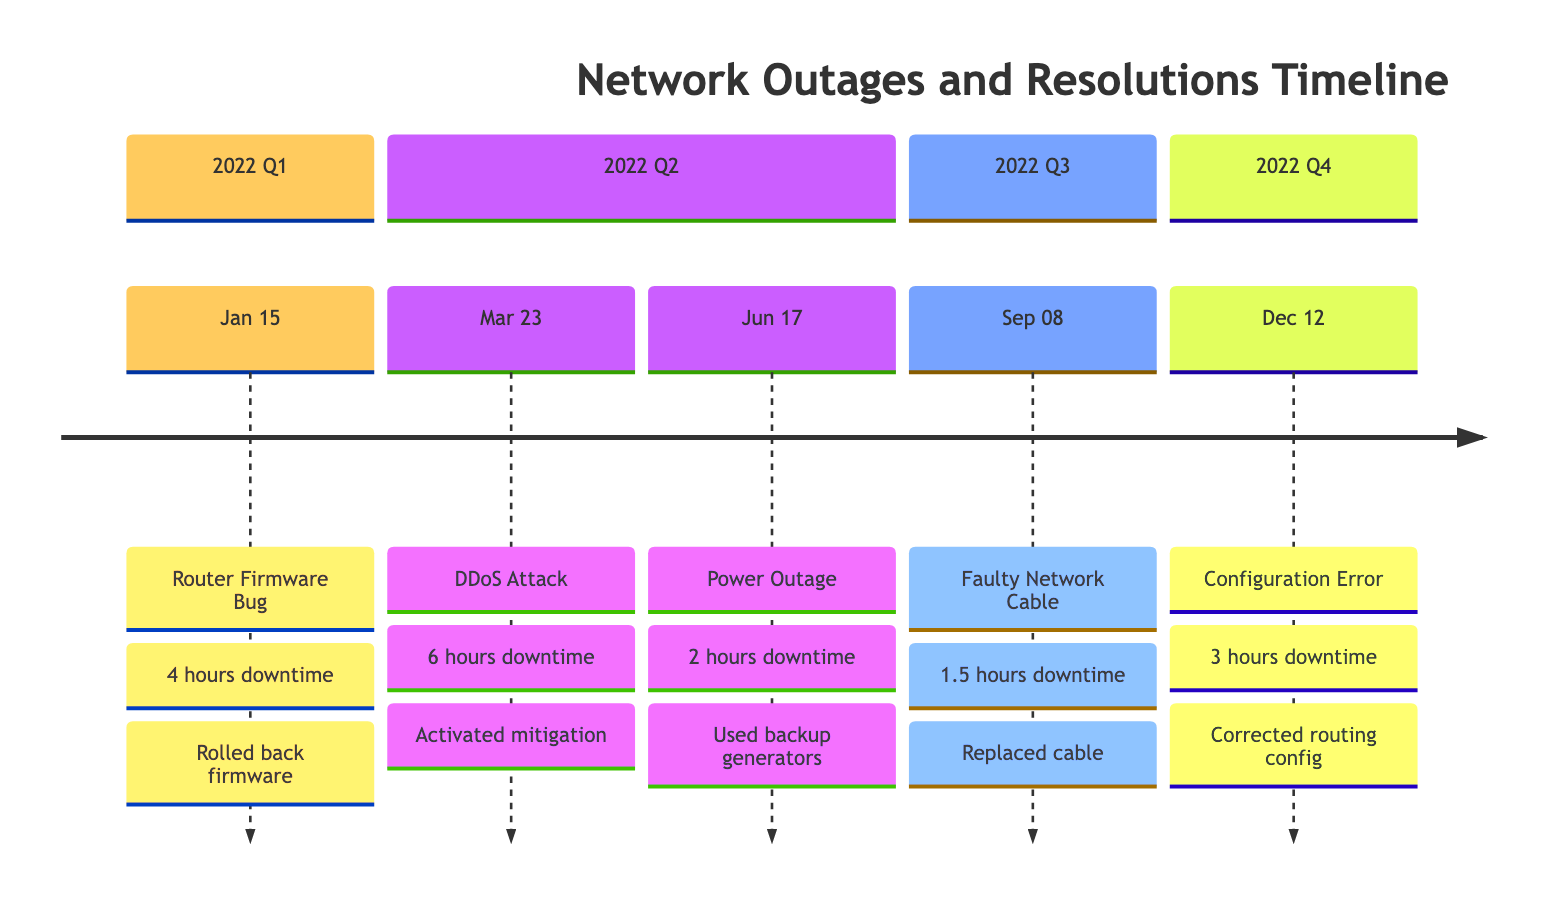What was the cause of the incident on January 15? The diagram indicates that the incident on January 15 was caused by a "Router Firmware Bug."
Answer: Router Firmware Bug How long did the DDoS attack last? The diagram shows that the DDoS attack on March 23 lasted for "6 hours."
Answer: 6 hours What resolution step was taken for the faulty network cable incident? The timeline details that one of the resolution steps for the faulty network cable incident on September 8 was to "Replace defective cable with a new one."
Answer: Replace defective cable with a new one Which incident had the shortest downtime? By reviewing the incident durations in the diagram, the incident on September 8 had the shortest downtime at "1.5 hours."
Answer: 1.5 hours What actions were taken for the power outage incident? The timeline includes multiple resolution steps for the power outage incident, one of which was "Switched to backup generators."
Answer: Switched to backup generators What type of attack occurred on March 23? The diagram indicates that the incident on March 23 was a "DDoS Attack."
Answer: DDoS Attack How many total incidents were recorded in 2022? The diagram lists a total of 5 incidents throughout the year, which can be counted from the sections.
Answer: 5 Which incident involved a configuration error? The diagram identifies that the incident on December 12 involved a "Configuration Error."
Answer: Configuration Error What was the first incident of the year? The diagram shows that the first incident of the year occurred on January 15.
Answer: January 15 